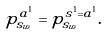<formula> <loc_0><loc_0><loc_500><loc_500>p ^ { a ^ { 1 } } _ { s _ { w } } = p ^ { s ^ { 1 } = a ^ { 1 } } _ { s _ { w } } .</formula> 